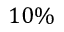Convert formula to latex. <formula><loc_0><loc_0><loc_500><loc_500>1 0 \%</formula> 